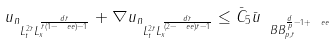<formula> <loc_0><loc_0><loc_500><loc_500>\| u _ { n } \| _ { L ^ { 2 \bar { r } } _ { t } L ^ { \frac { d \bar { r } } { \bar { r } ( 1 - \ e e ) - 1 } } _ { x } } + \| \nabla u _ { n } \| _ { L ^ { 2 \bar { r } } _ { t } L ^ { \frac { d \bar { r } } { ( 2 - \ e e ) \bar { r } - 1 } } _ { x } } \leq \bar { C } _ { 5 } \| \bar { u } \| _ { \ B B _ { p , \bar { r } } ^ { \frac { d } { p } - 1 + \ e e } }</formula> 